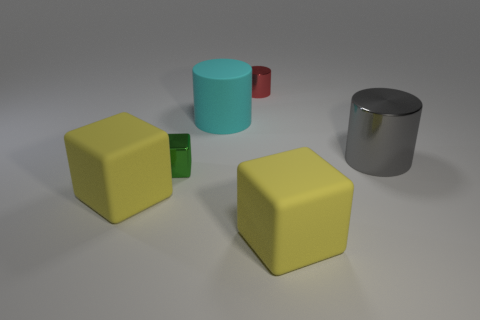What shape is the big thing that is behind the large gray metal thing?
Provide a short and direct response. Cylinder. There is a big object that is the same material as the green cube; what is its color?
Give a very brief answer. Gray. There is another small thing that is the same shape as the gray metal object; what material is it?
Make the answer very short. Metal. What shape is the cyan matte object?
Your answer should be very brief. Cylinder. There is a big thing that is right of the large cyan cylinder and in front of the green cube; what is it made of?
Give a very brief answer. Rubber. What is the shape of the big gray object that is made of the same material as the tiny green object?
Your answer should be compact. Cylinder. There is a red object that is made of the same material as the tiny green object; what is its size?
Keep it short and to the point. Small. What is the shape of the metallic object that is in front of the matte cylinder and to the left of the gray metallic cylinder?
Your response must be concise. Cube. What size is the matte cube behind the cube on the right side of the small green object?
Ensure brevity in your answer.  Large. What number of other objects are there of the same color as the small cylinder?
Offer a terse response. 0. 